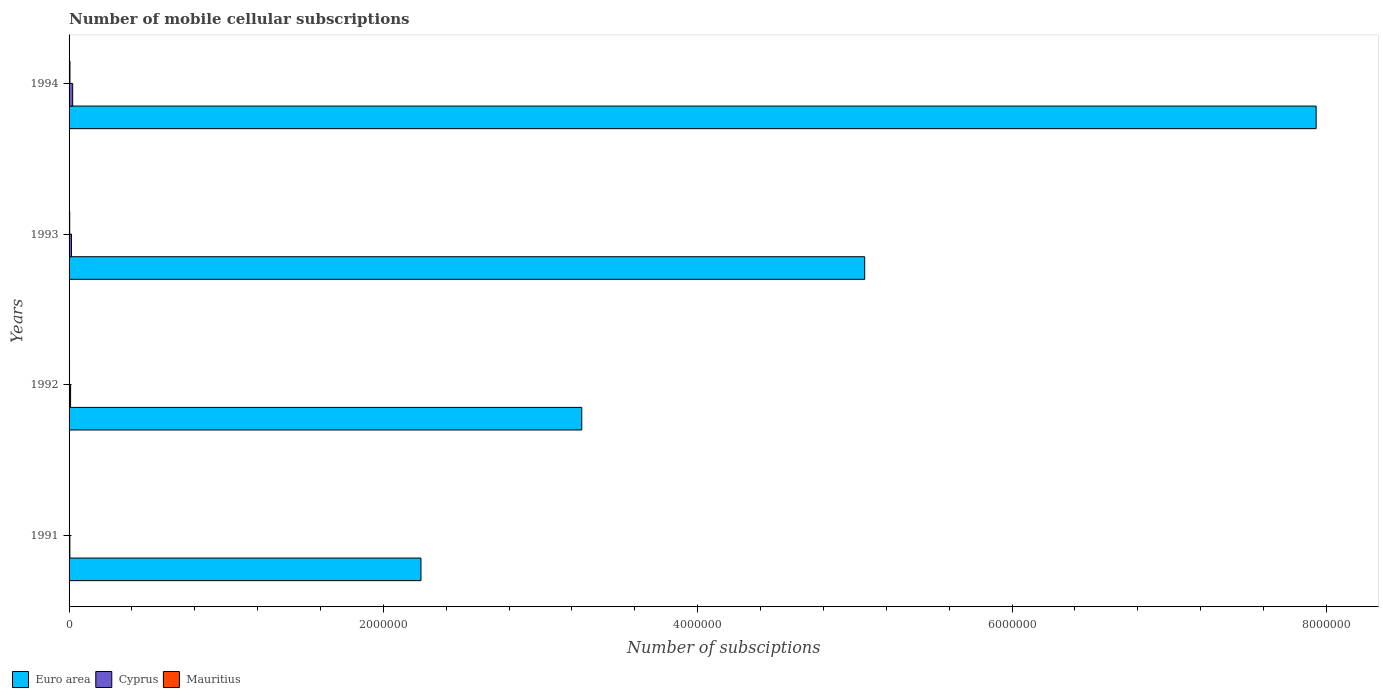Are the number of bars on each tick of the Y-axis equal?
Provide a short and direct response. Yes. How many bars are there on the 2nd tick from the top?
Provide a succinct answer. 3. What is the label of the 2nd group of bars from the top?
Give a very brief answer. 1993. In how many cases, is the number of bars for a given year not equal to the number of legend labels?
Your answer should be very brief. 0. What is the number of mobile cellular subscriptions in Mauritius in 1992?
Your response must be concise. 2912. Across all years, what is the maximum number of mobile cellular subscriptions in Cyprus?
Your response must be concise. 2.29e+04. Across all years, what is the minimum number of mobile cellular subscriptions in Mauritius?
Give a very brief answer. 2500. In which year was the number of mobile cellular subscriptions in Euro area maximum?
Your response must be concise. 1994. What is the total number of mobile cellular subscriptions in Euro area in the graph?
Make the answer very short. 1.85e+07. What is the difference between the number of mobile cellular subscriptions in Cyprus in 1992 and that in 1994?
Your answer should be compact. -1.32e+04. What is the difference between the number of mobile cellular subscriptions in Cyprus in 1993 and the number of mobile cellular subscriptions in Mauritius in 1994?
Offer a very short reply. 9582. What is the average number of mobile cellular subscriptions in Mauritius per year?
Make the answer very short. 3788.75. In the year 1992, what is the difference between the number of mobile cellular subscriptions in Euro area and number of mobile cellular subscriptions in Mauritius?
Give a very brief answer. 3.26e+06. What is the ratio of the number of mobile cellular subscriptions in Mauritius in 1992 to that in 1993?
Keep it short and to the point. 0.72. What is the difference between the highest and the second highest number of mobile cellular subscriptions in Mauritius?
Provide a succinct answer. 1669. What is the difference between the highest and the lowest number of mobile cellular subscriptions in Mauritius?
Provide a short and direct response. 3206. In how many years, is the number of mobile cellular subscriptions in Mauritius greater than the average number of mobile cellular subscriptions in Mauritius taken over all years?
Ensure brevity in your answer.  2. Is the sum of the number of mobile cellular subscriptions in Mauritius in 1992 and 1993 greater than the maximum number of mobile cellular subscriptions in Cyprus across all years?
Provide a succinct answer. No. What does the 3rd bar from the bottom in 1994 represents?
Give a very brief answer. Mauritius. How many bars are there?
Your response must be concise. 12. Does the graph contain any zero values?
Make the answer very short. No. How many legend labels are there?
Offer a terse response. 3. What is the title of the graph?
Make the answer very short. Number of mobile cellular subscriptions. What is the label or title of the X-axis?
Keep it short and to the point. Number of subsciptions. What is the label or title of the Y-axis?
Offer a terse response. Years. What is the Number of subsciptions of Euro area in 1991?
Your answer should be compact. 2.24e+06. What is the Number of subsciptions in Cyprus in 1991?
Make the answer very short. 5131. What is the Number of subsciptions of Mauritius in 1991?
Make the answer very short. 2500. What is the Number of subsciptions in Euro area in 1992?
Your answer should be very brief. 3.26e+06. What is the Number of subsciptions in Cyprus in 1992?
Provide a succinct answer. 9739. What is the Number of subsciptions in Mauritius in 1992?
Provide a short and direct response. 2912. What is the Number of subsciptions in Euro area in 1993?
Your answer should be very brief. 5.06e+06. What is the Number of subsciptions in Cyprus in 1993?
Your answer should be very brief. 1.53e+04. What is the Number of subsciptions of Mauritius in 1993?
Provide a succinct answer. 4037. What is the Number of subsciptions of Euro area in 1994?
Your answer should be compact. 7.94e+06. What is the Number of subsciptions in Cyprus in 1994?
Provide a succinct answer. 2.29e+04. What is the Number of subsciptions in Mauritius in 1994?
Offer a very short reply. 5706. Across all years, what is the maximum Number of subsciptions in Euro area?
Your answer should be very brief. 7.94e+06. Across all years, what is the maximum Number of subsciptions in Cyprus?
Your response must be concise. 2.29e+04. Across all years, what is the maximum Number of subsciptions of Mauritius?
Offer a very short reply. 5706. Across all years, what is the minimum Number of subsciptions of Euro area?
Give a very brief answer. 2.24e+06. Across all years, what is the minimum Number of subsciptions of Cyprus?
Provide a short and direct response. 5131. Across all years, what is the minimum Number of subsciptions of Mauritius?
Offer a terse response. 2500. What is the total Number of subsciptions of Euro area in the graph?
Offer a very short reply. 1.85e+07. What is the total Number of subsciptions of Cyprus in the graph?
Your answer should be very brief. 5.31e+04. What is the total Number of subsciptions in Mauritius in the graph?
Ensure brevity in your answer.  1.52e+04. What is the difference between the Number of subsciptions of Euro area in 1991 and that in 1992?
Your answer should be compact. -1.02e+06. What is the difference between the Number of subsciptions of Cyprus in 1991 and that in 1992?
Your response must be concise. -4608. What is the difference between the Number of subsciptions in Mauritius in 1991 and that in 1992?
Your answer should be very brief. -412. What is the difference between the Number of subsciptions in Euro area in 1991 and that in 1993?
Make the answer very short. -2.82e+06. What is the difference between the Number of subsciptions in Cyprus in 1991 and that in 1993?
Keep it short and to the point. -1.02e+04. What is the difference between the Number of subsciptions of Mauritius in 1991 and that in 1993?
Your answer should be very brief. -1537. What is the difference between the Number of subsciptions of Euro area in 1991 and that in 1994?
Provide a succinct answer. -5.70e+06. What is the difference between the Number of subsciptions in Cyprus in 1991 and that in 1994?
Keep it short and to the point. -1.78e+04. What is the difference between the Number of subsciptions in Mauritius in 1991 and that in 1994?
Give a very brief answer. -3206. What is the difference between the Number of subsciptions in Euro area in 1992 and that in 1993?
Your answer should be compact. -1.80e+06. What is the difference between the Number of subsciptions in Cyprus in 1992 and that in 1993?
Your answer should be very brief. -5549. What is the difference between the Number of subsciptions of Mauritius in 1992 and that in 1993?
Provide a short and direct response. -1125. What is the difference between the Number of subsciptions of Euro area in 1992 and that in 1994?
Provide a short and direct response. -4.67e+06. What is the difference between the Number of subsciptions in Cyprus in 1992 and that in 1994?
Offer a very short reply. -1.32e+04. What is the difference between the Number of subsciptions in Mauritius in 1992 and that in 1994?
Your answer should be compact. -2794. What is the difference between the Number of subsciptions in Euro area in 1993 and that in 1994?
Keep it short and to the point. -2.87e+06. What is the difference between the Number of subsciptions of Cyprus in 1993 and that in 1994?
Offer a terse response. -7650. What is the difference between the Number of subsciptions in Mauritius in 1993 and that in 1994?
Offer a very short reply. -1669. What is the difference between the Number of subsciptions in Euro area in 1991 and the Number of subsciptions in Cyprus in 1992?
Your answer should be compact. 2.23e+06. What is the difference between the Number of subsciptions in Euro area in 1991 and the Number of subsciptions in Mauritius in 1992?
Keep it short and to the point. 2.24e+06. What is the difference between the Number of subsciptions in Cyprus in 1991 and the Number of subsciptions in Mauritius in 1992?
Provide a succinct answer. 2219. What is the difference between the Number of subsciptions in Euro area in 1991 and the Number of subsciptions in Cyprus in 1993?
Make the answer very short. 2.22e+06. What is the difference between the Number of subsciptions of Euro area in 1991 and the Number of subsciptions of Mauritius in 1993?
Provide a succinct answer. 2.23e+06. What is the difference between the Number of subsciptions in Cyprus in 1991 and the Number of subsciptions in Mauritius in 1993?
Your answer should be very brief. 1094. What is the difference between the Number of subsciptions of Euro area in 1991 and the Number of subsciptions of Cyprus in 1994?
Make the answer very short. 2.22e+06. What is the difference between the Number of subsciptions in Euro area in 1991 and the Number of subsciptions in Mauritius in 1994?
Your response must be concise. 2.23e+06. What is the difference between the Number of subsciptions of Cyprus in 1991 and the Number of subsciptions of Mauritius in 1994?
Make the answer very short. -575. What is the difference between the Number of subsciptions of Euro area in 1992 and the Number of subsciptions of Cyprus in 1993?
Make the answer very short. 3.25e+06. What is the difference between the Number of subsciptions of Euro area in 1992 and the Number of subsciptions of Mauritius in 1993?
Offer a terse response. 3.26e+06. What is the difference between the Number of subsciptions in Cyprus in 1992 and the Number of subsciptions in Mauritius in 1993?
Offer a very short reply. 5702. What is the difference between the Number of subsciptions in Euro area in 1992 and the Number of subsciptions in Cyprus in 1994?
Give a very brief answer. 3.24e+06. What is the difference between the Number of subsciptions of Euro area in 1992 and the Number of subsciptions of Mauritius in 1994?
Offer a terse response. 3.26e+06. What is the difference between the Number of subsciptions in Cyprus in 1992 and the Number of subsciptions in Mauritius in 1994?
Offer a terse response. 4033. What is the difference between the Number of subsciptions in Euro area in 1993 and the Number of subsciptions in Cyprus in 1994?
Make the answer very short. 5.04e+06. What is the difference between the Number of subsciptions of Euro area in 1993 and the Number of subsciptions of Mauritius in 1994?
Offer a terse response. 5.06e+06. What is the difference between the Number of subsciptions in Cyprus in 1993 and the Number of subsciptions in Mauritius in 1994?
Provide a succinct answer. 9582. What is the average Number of subsciptions of Euro area per year?
Offer a very short reply. 4.62e+06. What is the average Number of subsciptions in Cyprus per year?
Provide a succinct answer. 1.33e+04. What is the average Number of subsciptions of Mauritius per year?
Offer a very short reply. 3788.75. In the year 1991, what is the difference between the Number of subsciptions in Euro area and Number of subsciptions in Cyprus?
Your answer should be compact. 2.23e+06. In the year 1991, what is the difference between the Number of subsciptions in Euro area and Number of subsciptions in Mauritius?
Your answer should be very brief. 2.24e+06. In the year 1991, what is the difference between the Number of subsciptions of Cyprus and Number of subsciptions of Mauritius?
Make the answer very short. 2631. In the year 1992, what is the difference between the Number of subsciptions in Euro area and Number of subsciptions in Cyprus?
Provide a succinct answer. 3.25e+06. In the year 1992, what is the difference between the Number of subsciptions in Euro area and Number of subsciptions in Mauritius?
Offer a very short reply. 3.26e+06. In the year 1992, what is the difference between the Number of subsciptions in Cyprus and Number of subsciptions in Mauritius?
Offer a terse response. 6827. In the year 1993, what is the difference between the Number of subsciptions of Euro area and Number of subsciptions of Cyprus?
Your answer should be compact. 5.05e+06. In the year 1993, what is the difference between the Number of subsciptions in Euro area and Number of subsciptions in Mauritius?
Provide a succinct answer. 5.06e+06. In the year 1993, what is the difference between the Number of subsciptions in Cyprus and Number of subsciptions in Mauritius?
Give a very brief answer. 1.13e+04. In the year 1994, what is the difference between the Number of subsciptions in Euro area and Number of subsciptions in Cyprus?
Your response must be concise. 7.91e+06. In the year 1994, what is the difference between the Number of subsciptions in Euro area and Number of subsciptions in Mauritius?
Your answer should be very brief. 7.93e+06. In the year 1994, what is the difference between the Number of subsciptions of Cyprus and Number of subsciptions of Mauritius?
Ensure brevity in your answer.  1.72e+04. What is the ratio of the Number of subsciptions of Euro area in 1991 to that in 1992?
Your answer should be compact. 0.69. What is the ratio of the Number of subsciptions of Cyprus in 1991 to that in 1992?
Your answer should be very brief. 0.53. What is the ratio of the Number of subsciptions of Mauritius in 1991 to that in 1992?
Offer a very short reply. 0.86. What is the ratio of the Number of subsciptions of Euro area in 1991 to that in 1993?
Offer a very short reply. 0.44. What is the ratio of the Number of subsciptions in Cyprus in 1991 to that in 1993?
Your answer should be compact. 0.34. What is the ratio of the Number of subsciptions of Mauritius in 1991 to that in 1993?
Your answer should be compact. 0.62. What is the ratio of the Number of subsciptions in Euro area in 1991 to that in 1994?
Ensure brevity in your answer.  0.28. What is the ratio of the Number of subsciptions of Cyprus in 1991 to that in 1994?
Offer a very short reply. 0.22. What is the ratio of the Number of subsciptions in Mauritius in 1991 to that in 1994?
Your answer should be very brief. 0.44. What is the ratio of the Number of subsciptions in Euro area in 1992 to that in 1993?
Your response must be concise. 0.64. What is the ratio of the Number of subsciptions of Cyprus in 1992 to that in 1993?
Your answer should be very brief. 0.64. What is the ratio of the Number of subsciptions in Mauritius in 1992 to that in 1993?
Offer a terse response. 0.72. What is the ratio of the Number of subsciptions of Euro area in 1992 to that in 1994?
Make the answer very short. 0.41. What is the ratio of the Number of subsciptions of Cyprus in 1992 to that in 1994?
Give a very brief answer. 0.42. What is the ratio of the Number of subsciptions in Mauritius in 1992 to that in 1994?
Your answer should be compact. 0.51. What is the ratio of the Number of subsciptions of Euro area in 1993 to that in 1994?
Provide a short and direct response. 0.64. What is the ratio of the Number of subsciptions in Cyprus in 1993 to that in 1994?
Make the answer very short. 0.67. What is the ratio of the Number of subsciptions of Mauritius in 1993 to that in 1994?
Your response must be concise. 0.71. What is the difference between the highest and the second highest Number of subsciptions of Euro area?
Ensure brevity in your answer.  2.87e+06. What is the difference between the highest and the second highest Number of subsciptions of Cyprus?
Make the answer very short. 7650. What is the difference between the highest and the second highest Number of subsciptions of Mauritius?
Offer a terse response. 1669. What is the difference between the highest and the lowest Number of subsciptions of Euro area?
Give a very brief answer. 5.70e+06. What is the difference between the highest and the lowest Number of subsciptions in Cyprus?
Your answer should be compact. 1.78e+04. What is the difference between the highest and the lowest Number of subsciptions of Mauritius?
Your answer should be very brief. 3206. 